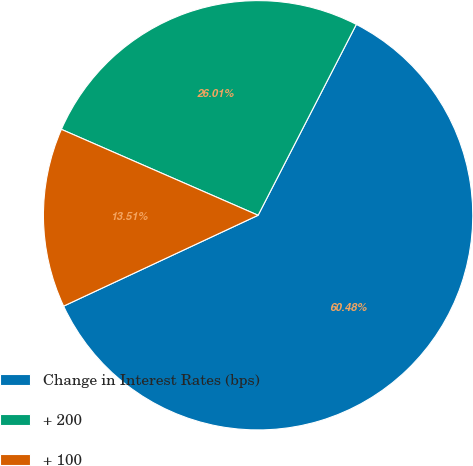<chart> <loc_0><loc_0><loc_500><loc_500><pie_chart><fcel>Change in Interest Rates (bps)<fcel>+ 200<fcel>+ 100<nl><fcel>60.48%<fcel>26.01%<fcel>13.51%<nl></chart> 